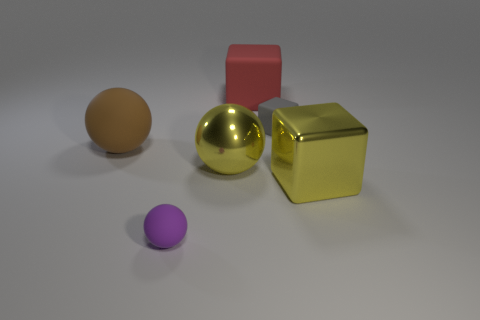Subtract all big matte cubes. How many cubes are left? 2 Add 4 large brown rubber things. How many objects exist? 10 Add 2 red cubes. How many red cubes are left? 3 Add 4 yellow metallic objects. How many yellow metallic objects exist? 6 Subtract 0 gray cylinders. How many objects are left? 6 Subtract all red blocks. Subtract all blue cylinders. How many blocks are left? 2 Subtract all yellow blocks. Subtract all red things. How many objects are left? 4 